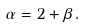Convert formula to latex. <formula><loc_0><loc_0><loc_500><loc_500>\alpha = 2 + \beta \, .</formula> 